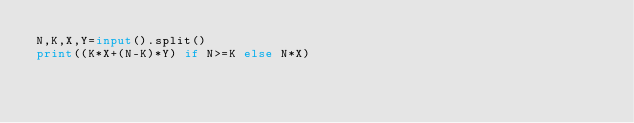Convert code to text. <code><loc_0><loc_0><loc_500><loc_500><_Python_>N,K,X,Y=input().split()
print((K*X+(N-K)*Y) if N>=K else N*X)</code> 